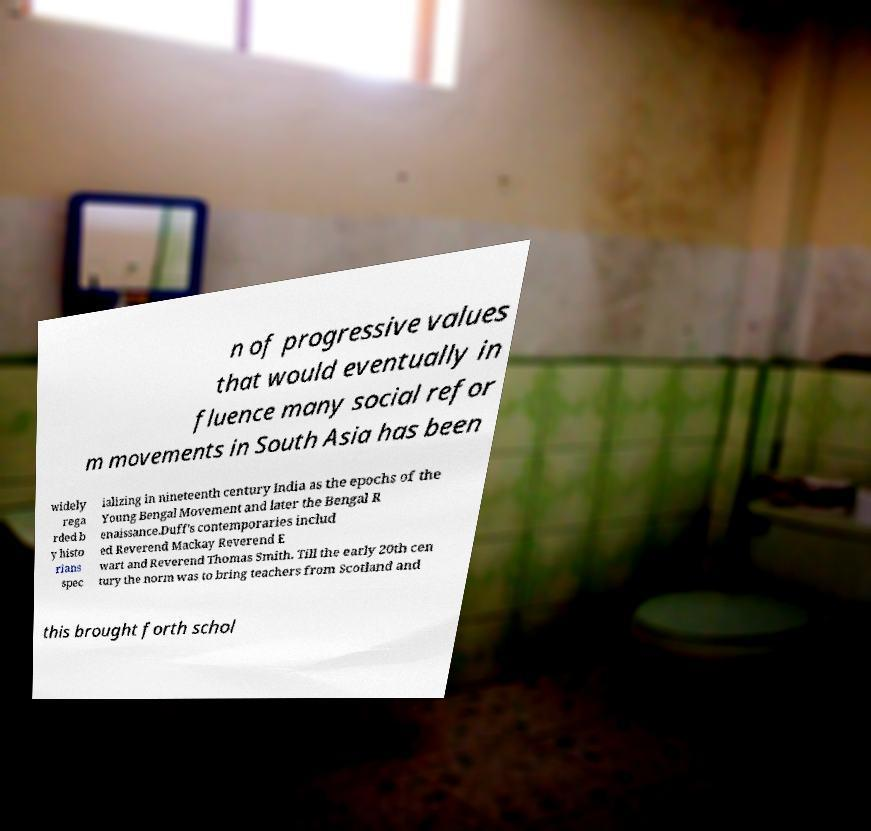Please read and relay the text visible in this image. What does it say? n of progressive values that would eventually in fluence many social refor m movements in South Asia has been widely rega rded b y histo rians spec ializing in nineteenth century India as the epochs of the Young Bengal Movement and later the Bengal R enaissance.Duff's contemporaries includ ed Reverend Mackay Reverend E wart and Reverend Thomas Smith. Till the early 20th cen tury the norm was to bring teachers from Scotland and this brought forth schol 